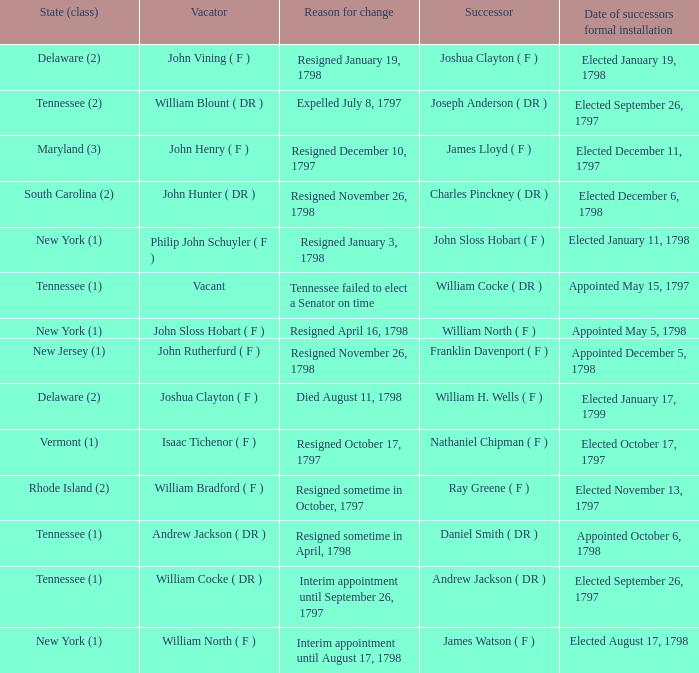What is the number of vacators when the successor was William H. Wells ( F )? 1.0. 